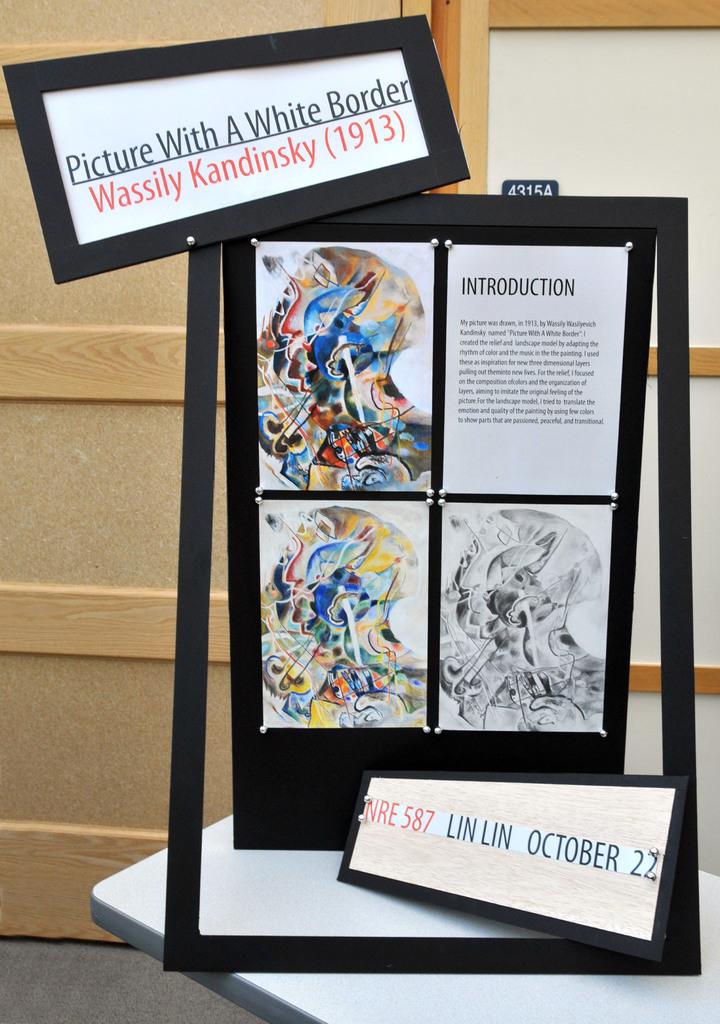What is the title of this piece?
Your answer should be very brief. Picture with a white border. What year did kandinsky paint this?
Your answer should be compact. 1913. 